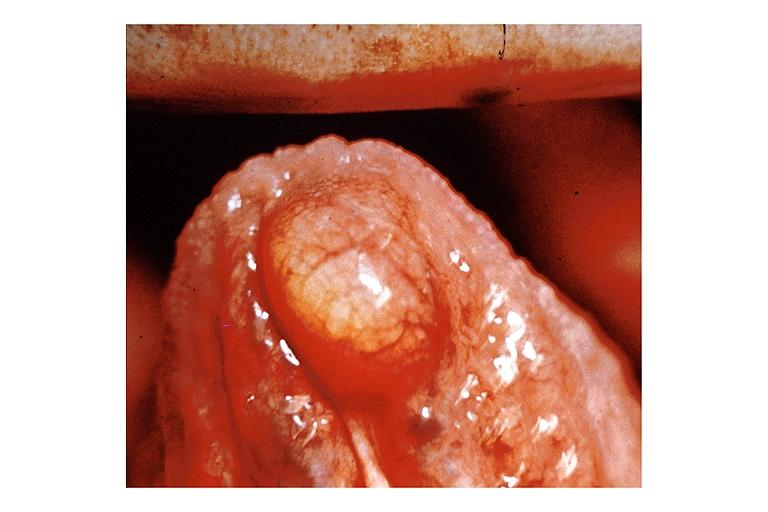where is this?
Answer the question using a single word or phrase. Oral 